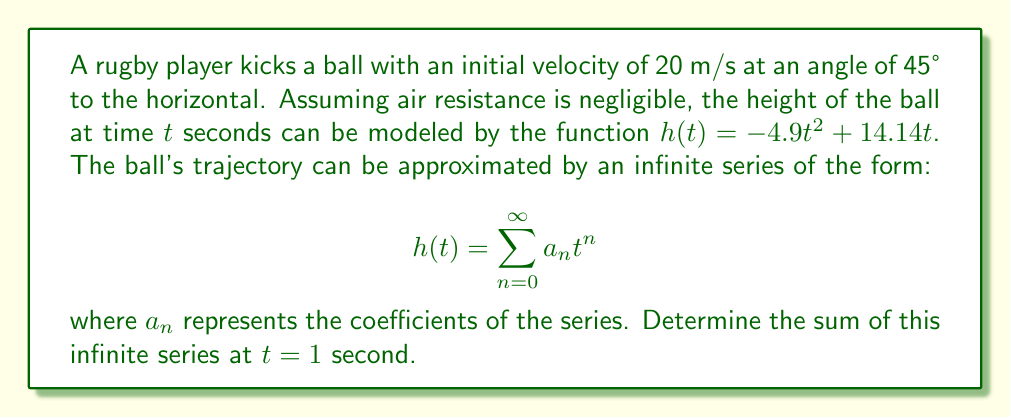Could you help me with this problem? Let's approach this step-by-step:

1) First, we need to identify the coefficients of our series. Comparing our function to the general form of a power series, we can see that:

   $a_0 = 0$
   $a_1 = 14.14$
   $a_2 = -4.9$
   $a_n = 0$ for all $n \geq 3$

2) Now, our series becomes:

   $$h(t) = 0 + 14.14t - 4.9t^2 + 0t^3 + 0t^4 + ...$$

3) We're asked to find the sum of this series at $t = 1$. When we substitute $t = 1$, each term becomes simply its coefficient:

   $$h(1) = 0 + 14.14 - 4.9 + 0 + 0 + ...$$

4) Adding these terms:

   $$h(1) = 14.14 - 4.9 = 9.24$$

5) This result makes sense in the context of rugby ball trajectory. At 1 second after the kick, the ball would be approximately 9.24 meters above the ground, accounting for the upward velocity imparted by the kick and the downward acceleration due to gravity.
Answer: $9.24$ meters 